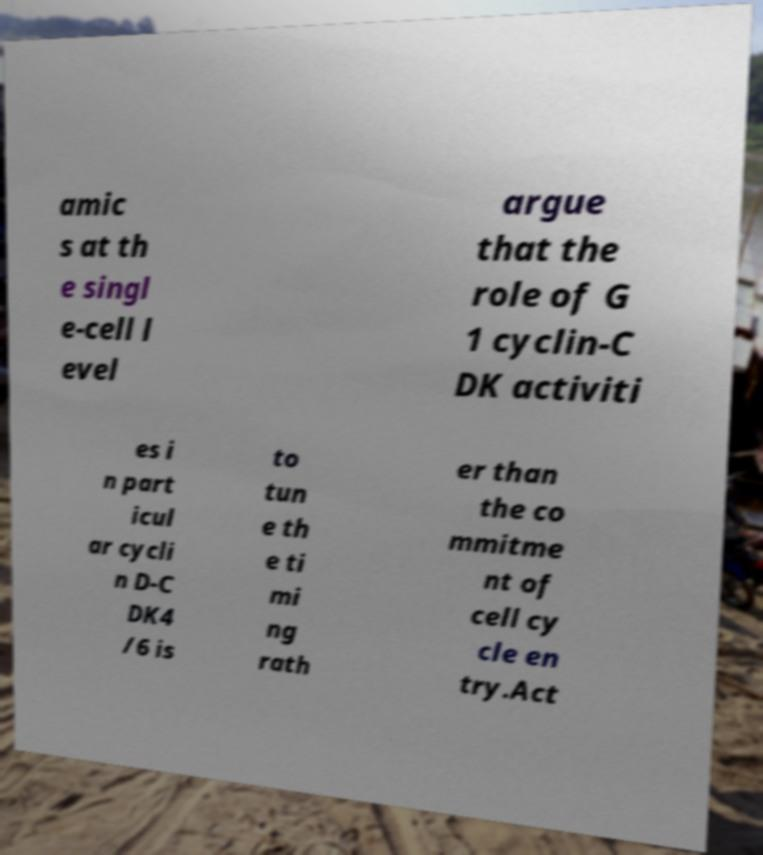I need the written content from this picture converted into text. Can you do that? amic s at th e singl e-cell l evel argue that the role of G 1 cyclin-C DK activiti es i n part icul ar cycli n D-C DK4 /6 is to tun e th e ti mi ng rath er than the co mmitme nt of cell cy cle en try.Act 